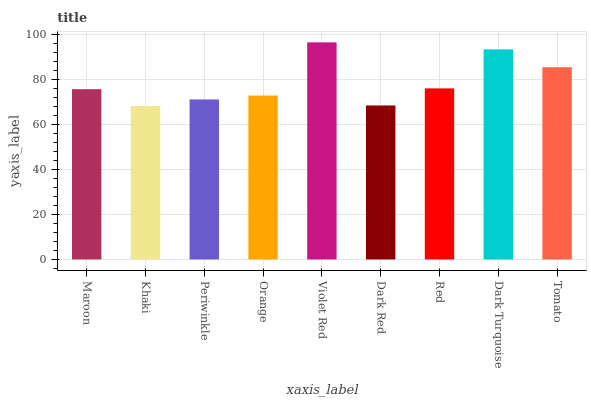Is Khaki the minimum?
Answer yes or no. Yes. Is Violet Red the maximum?
Answer yes or no. Yes. Is Periwinkle the minimum?
Answer yes or no. No. Is Periwinkle the maximum?
Answer yes or no. No. Is Periwinkle greater than Khaki?
Answer yes or no. Yes. Is Khaki less than Periwinkle?
Answer yes or no. Yes. Is Khaki greater than Periwinkle?
Answer yes or no. No. Is Periwinkle less than Khaki?
Answer yes or no. No. Is Maroon the high median?
Answer yes or no. Yes. Is Maroon the low median?
Answer yes or no. Yes. Is Red the high median?
Answer yes or no. No. Is Violet Red the low median?
Answer yes or no. No. 